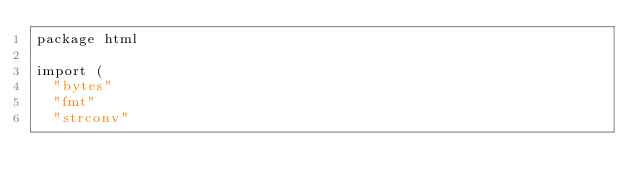Convert code to text. <code><loc_0><loc_0><loc_500><loc_500><_Go_>package html

import (
	"bytes"
	"fmt"
	"strconv"
</code> 